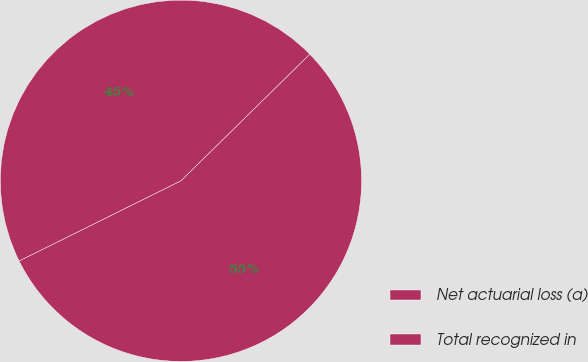Convert chart to OTSL. <chart><loc_0><loc_0><loc_500><loc_500><pie_chart><fcel>Net actuarial loss (a)<fcel>Total recognized in<nl><fcel>55.04%<fcel>44.96%<nl></chart> 